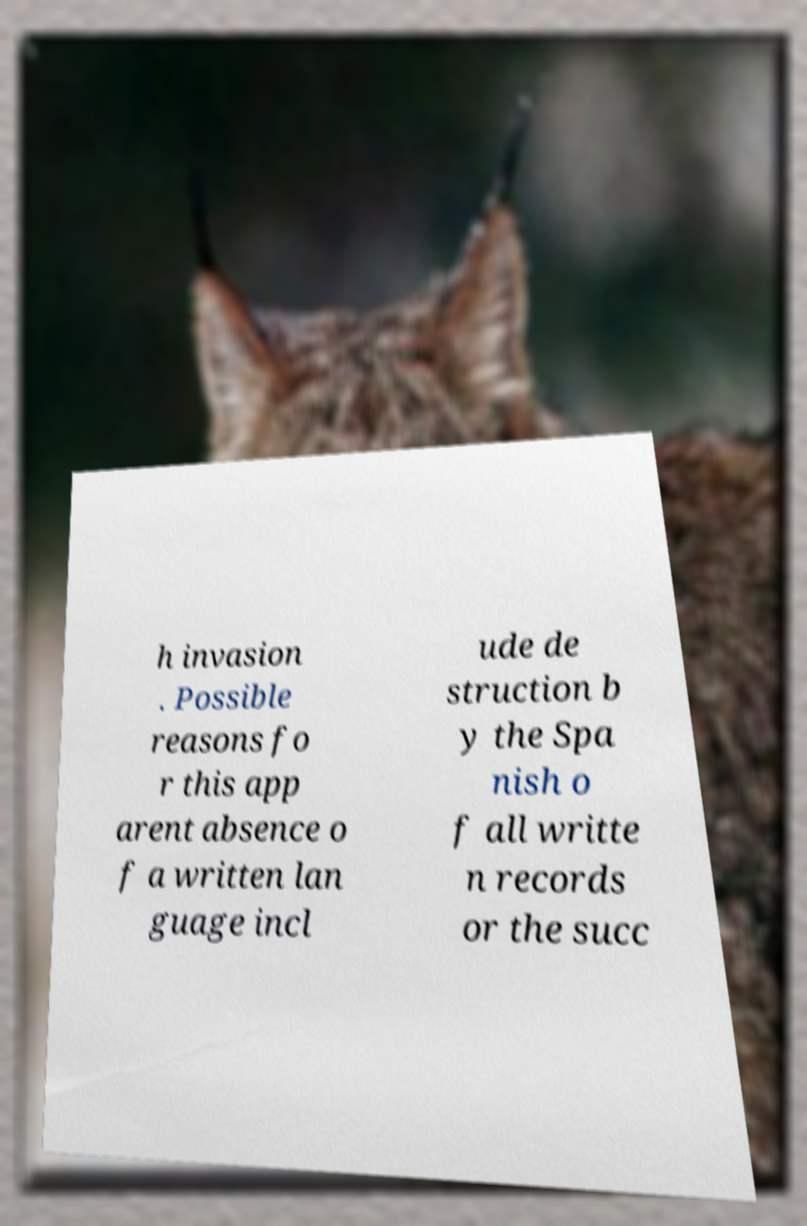What messages or text are displayed in this image? I need them in a readable, typed format. h invasion . Possible reasons fo r this app arent absence o f a written lan guage incl ude de struction b y the Spa nish o f all writte n records or the succ 